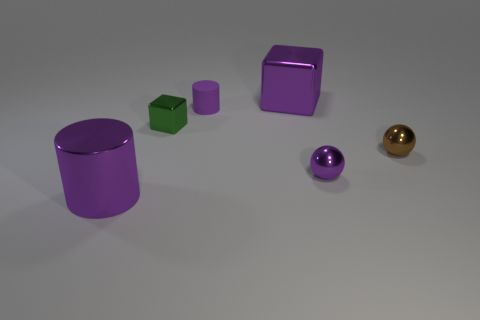Add 3 small purple matte spheres. How many objects exist? 9 Subtract all cubes. How many objects are left? 4 Subtract 1 purple spheres. How many objects are left? 5 Subtract all small green shiny cubes. Subtract all big balls. How many objects are left? 5 Add 2 tiny purple shiny balls. How many tiny purple shiny balls are left? 3 Add 1 small metallic cubes. How many small metallic cubes exist? 2 